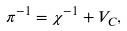Convert formula to latex. <formula><loc_0><loc_0><loc_500><loc_500>\pi ^ { - 1 } = \chi ^ { - 1 } + V _ { C } ,</formula> 